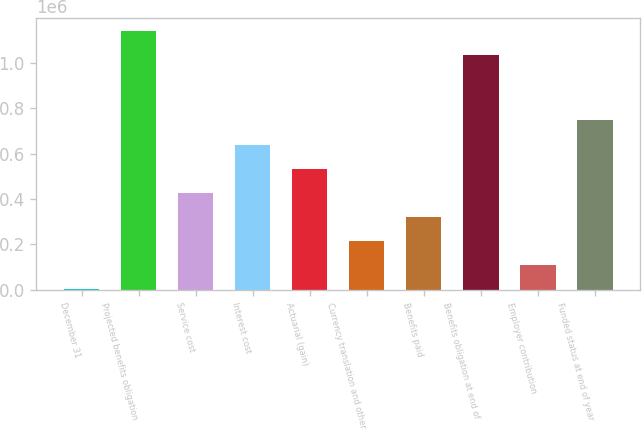<chart> <loc_0><loc_0><loc_500><loc_500><bar_chart><fcel>December 31<fcel>Projected benefits obligation<fcel>Service cost<fcel>Interest cost<fcel>Actuarial (gain)<fcel>Currency translation and other<fcel>Benefits paid<fcel>Benefits obligation at end of<fcel>Employer contribution<fcel>Funded status at end of year<nl><fcel>2007<fcel>1.13966e+06<fcel>427341<fcel>640008<fcel>533674<fcel>214674<fcel>321008<fcel>1.03332e+06<fcel>108340<fcel>746342<nl></chart> 